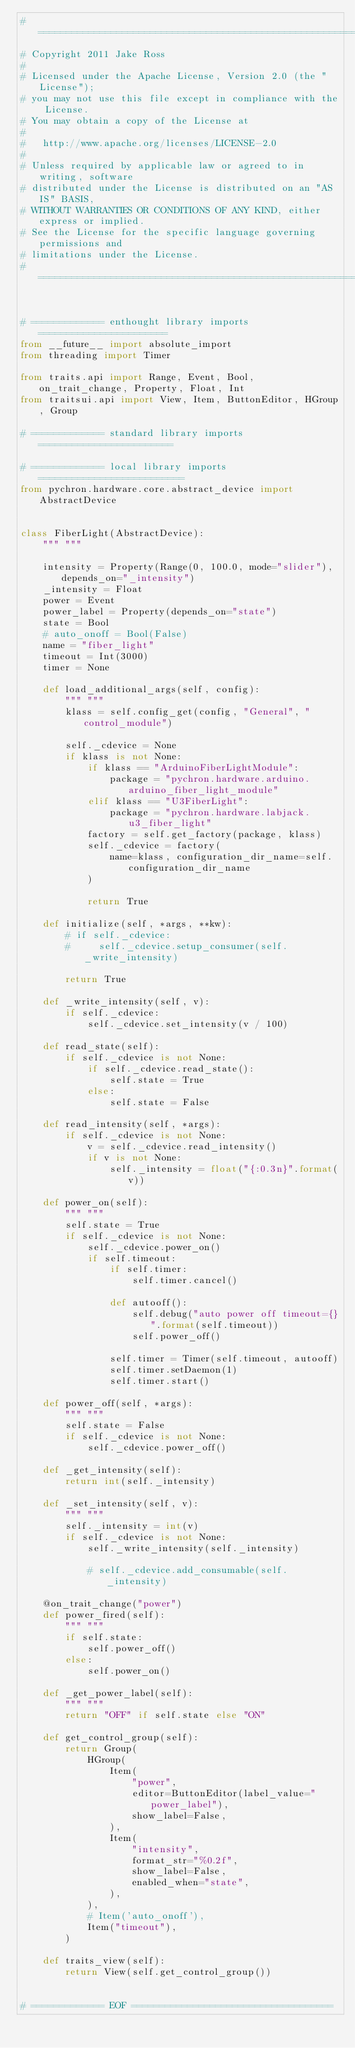Convert code to text. <code><loc_0><loc_0><loc_500><loc_500><_Python_># ===============================================================================
# Copyright 2011 Jake Ross
#
# Licensed under the Apache License, Version 2.0 (the "License");
# you may not use this file except in compliance with the License.
# You may obtain a copy of the License at
#
#   http://www.apache.org/licenses/LICENSE-2.0
#
# Unless required by applicable law or agreed to in writing, software
# distributed under the License is distributed on an "AS IS" BASIS,
# WITHOUT WARRANTIES OR CONDITIONS OF ANY KIND, either express or implied.
# See the License for the specific language governing permissions and
# limitations under the License.
# ===============================================================================


# ============= enthought library imports =======================
from __future__ import absolute_import
from threading import Timer

from traits.api import Range, Event, Bool, on_trait_change, Property, Float, Int
from traitsui.api import View, Item, ButtonEditor, HGroup, Group

# ============= standard library imports ========================

# ============= local library imports  ==========================
from pychron.hardware.core.abstract_device import AbstractDevice


class FiberLight(AbstractDevice):
    """ """

    intensity = Property(Range(0, 100.0, mode="slider"), depends_on="_intensity")
    _intensity = Float
    power = Event
    power_label = Property(depends_on="state")
    state = Bool
    # auto_onoff = Bool(False)
    name = "fiber_light"
    timeout = Int(3000)
    timer = None

    def load_additional_args(self, config):
        """ """
        klass = self.config_get(config, "General", "control_module")

        self._cdevice = None
        if klass is not None:
            if klass == "ArduinoFiberLightModule":
                package = "pychron.hardware.arduino.arduino_fiber_light_module"
            elif klass == "U3FiberLight":
                package = "pychron.hardware.labjack.u3_fiber_light"
            factory = self.get_factory(package, klass)
            self._cdevice = factory(
                name=klass, configuration_dir_name=self.configuration_dir_name
            )

            return True

    def initialize(self, *args, **kw):
        # if self._cdevice:
        #     self._cdevice.setup_consumer(self._write_intensity)

        return True

    def _write_intensity(self, v):
        if self._cdevice:
            self._cdevice.set_intensity(v / 100)

    def read_state(self):
        if self._cdevice is not None:
            if self._cdevice.read_state():
                self.state = True
            else:
                self.state = False

    def read_intensity(self, *args):
        if self._cdevice is not None:
            v = self._cdevice.read_intensity()
            if v is not None:
                self._intensity = float("{:0.3n}".format(v))

    def power_on(self):
        """ """
        self.state = True
        if self._cdevice is not None:
            self._cdevice.power_on()
            if self.timeout:
                if self.timer:
                    self.timer.cancel()

                def autooff():
                    self.debug("auto power off timeout={}".format(self.timeout))
                    self.power_off()

                self.timer = Timer(self.timeout, autooff)
                self.timer.setDaemon(1)
                self.timer.start()

    def power_off(self, *args):
        """ """
        self.state = False
        if self._cdevice is not None:
            self._cdevice.power_off()

    def _get_intensity(self):
        return int(self._intensity)

    def _set_intensity(self, v):
        """ """
        self._intensity = int(v)
        if self._cdevice is not None:
            self._write_intensity(self._intensity)

            # self._cdevice.add_consumable(self._intensity)

    @on_trait_change("power")
    def power_fired(self):
        """ """
        if self.state:
            self.power_off()
        else:
            self.power_on()

    def _get_power_label(self):
        """ """
        return "OFF" if self.state else "ON"

    def get_control_group(self):
        return Group(
            HGroup(
                Item(
                    "power",
                    editor=ButtonEditor(label_value="power_label"),
                    show_label=False,
                ),
                Item(
                    "intensity",
                    format_str="%0.2f",
                    show_label=False,
                    enabled_when="state",
                ),
            ),
            # Item('auto_onoff'),
            Item("timeout"),
        )

    def traits_view(self):
        return View(self.get_control_group())


# ============= EOF ====================================
</code> 